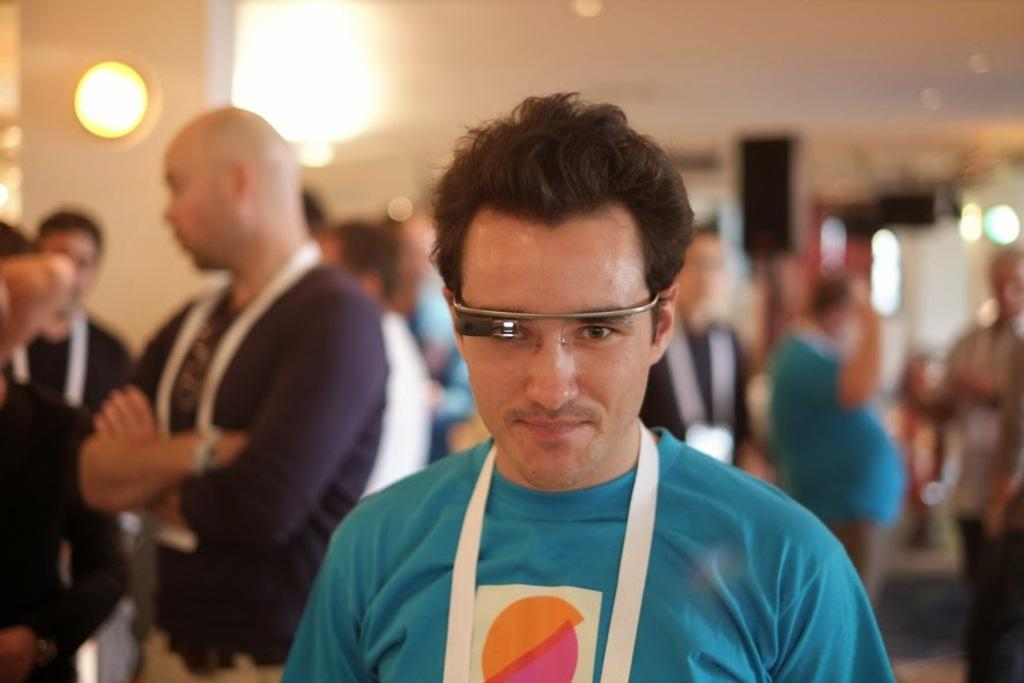What is the person in the image wearing? The person is wearing a blue dress in the image. Can you describe any accessories the person is wearing? The person is wearing spectacles. Are there any other people visible in the image? Yes, there are other persons standing behind the person in the blue dress. What type of hat is the person wearing in the image? There is no hat visible in the image; the person is wearing a blue dress and spectacles. What is the weather like in the image? The provided facts do not mention the weather, so it cannot be determined from the image. 